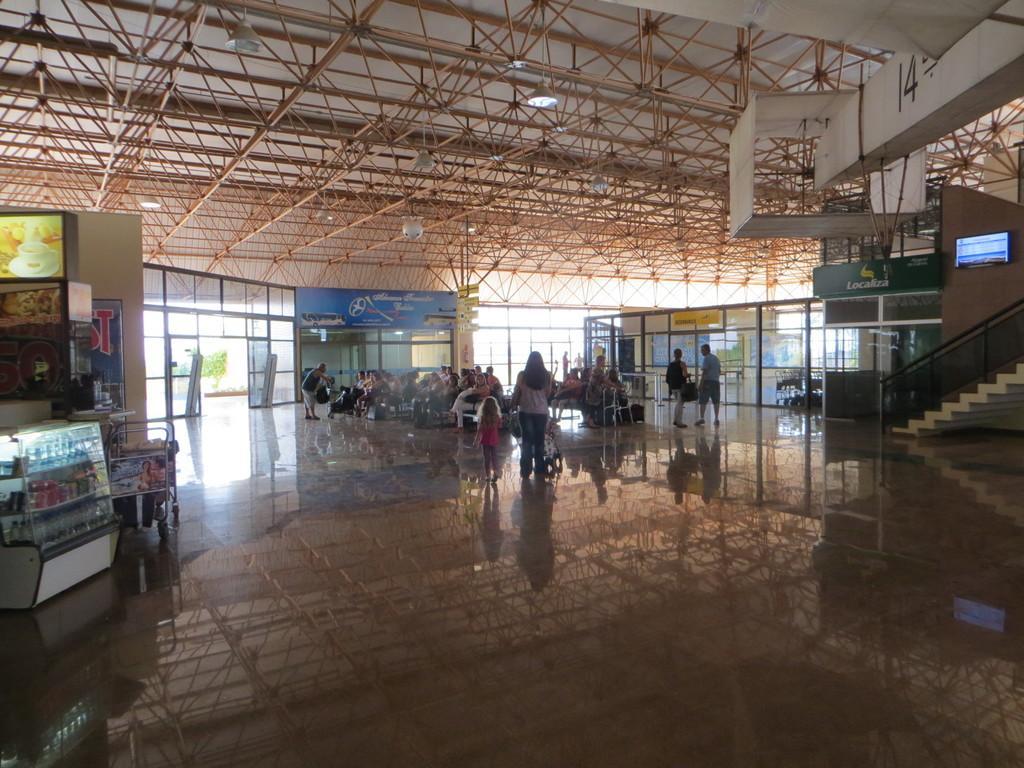Could you give a brief overview of what you see in this image? In this image, we can see persons wearing clothes. There is a counter on the left side of the image. There is a staircase on the right side of the image. There is a screen on the wall. There are lights hanging from the roof. 